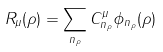<formula> <loc_0><loc_0><loc_500><loc_500>R _ { \mu } ( \rho ) = \sum _ { n _ { \rho } } C _ { n _ { \rho } } ^ { \mu } \phi _ { n _ { \rho } } ( \rho )</formula> 